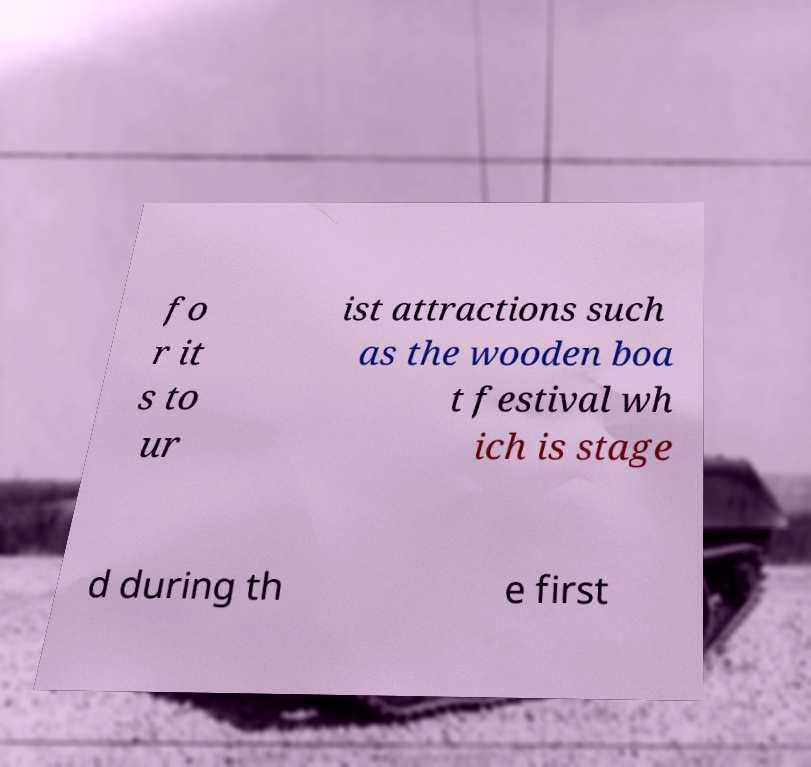There's text embedded in this image that I need extracted. Can you transcribe it verbatim? fo r it s to ur ist attractions such as the wooden boa t festival wh ich is stage d during th e first 